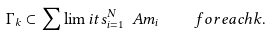<formula> <loc_0><loc_0><loc_500><loc_500>\Gamma _ { k } \subset \sum \lim i t s _ { i = 1 } ^ { N } \ A m _ { i } \quad f o r e a c h k .</formula> 